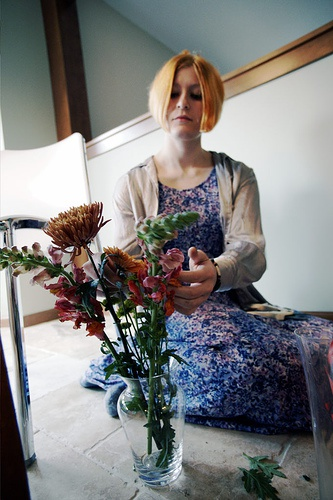Describe the objects in this image and their specific colors. I can see people in black, gray, darkgray, and navy tones and vase in black, darkgray, and gray tones in this image. 